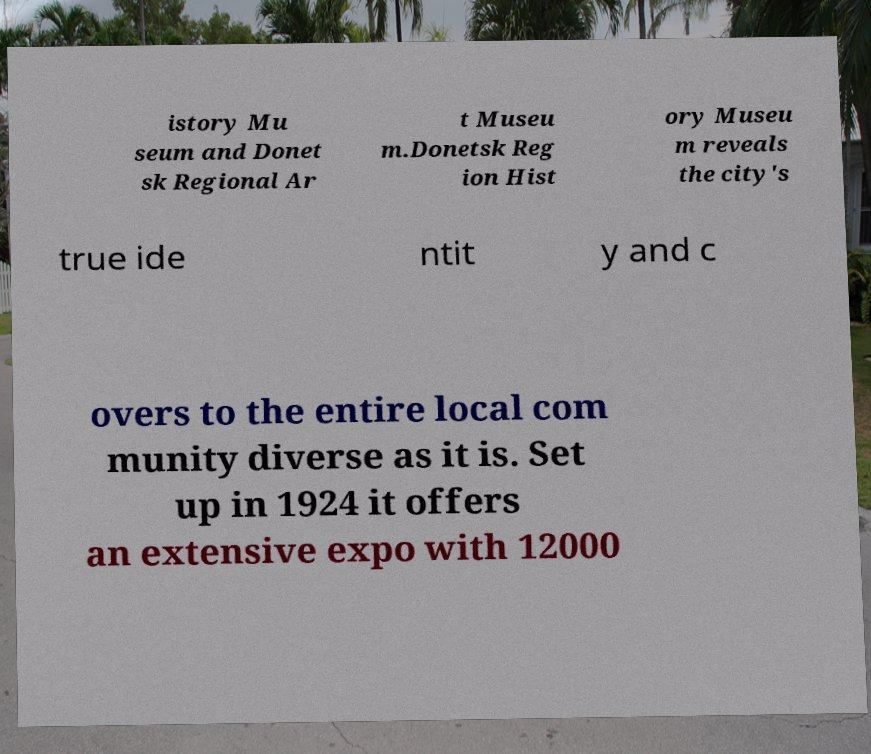There's text embedded in this image that I need extracted. Can you transcribe it verbatim? istory Mu seum and Donet sk Regional Ar t Museu m.Donetsk Reg ion Hist ory Museu m reveals the city's true ide ntit y and c overs to the entire local com munity diverse as it is. Set up in 1924 it offers an extensive expo with 12000 